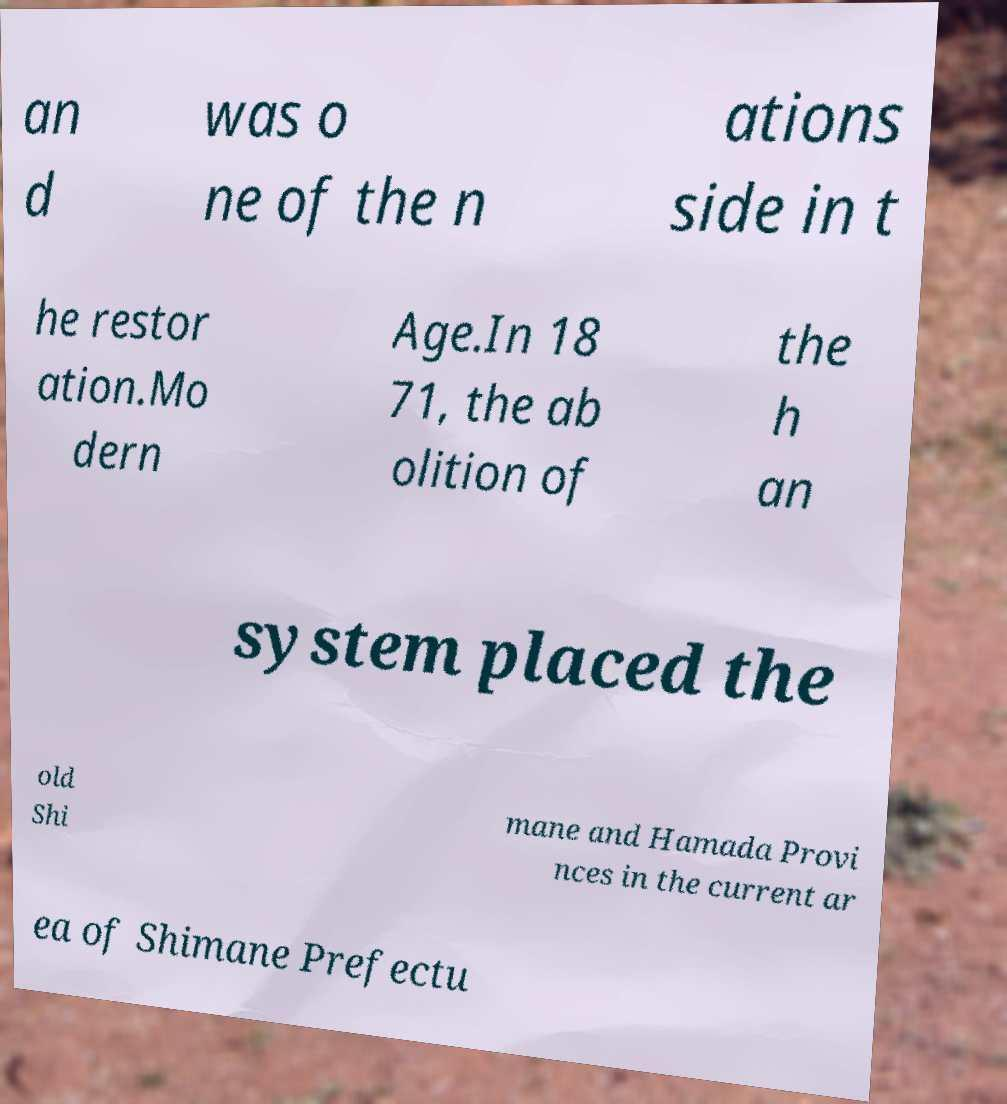Could you extract and type out the text from this image? an d was o ne of the n ations side in t he restor ation.Mo dern Age.In 18 71, the ab olition of the h an system placed the old Shi mane and Hamada Provi nces in the current ar ea of Shimane Prefectu 